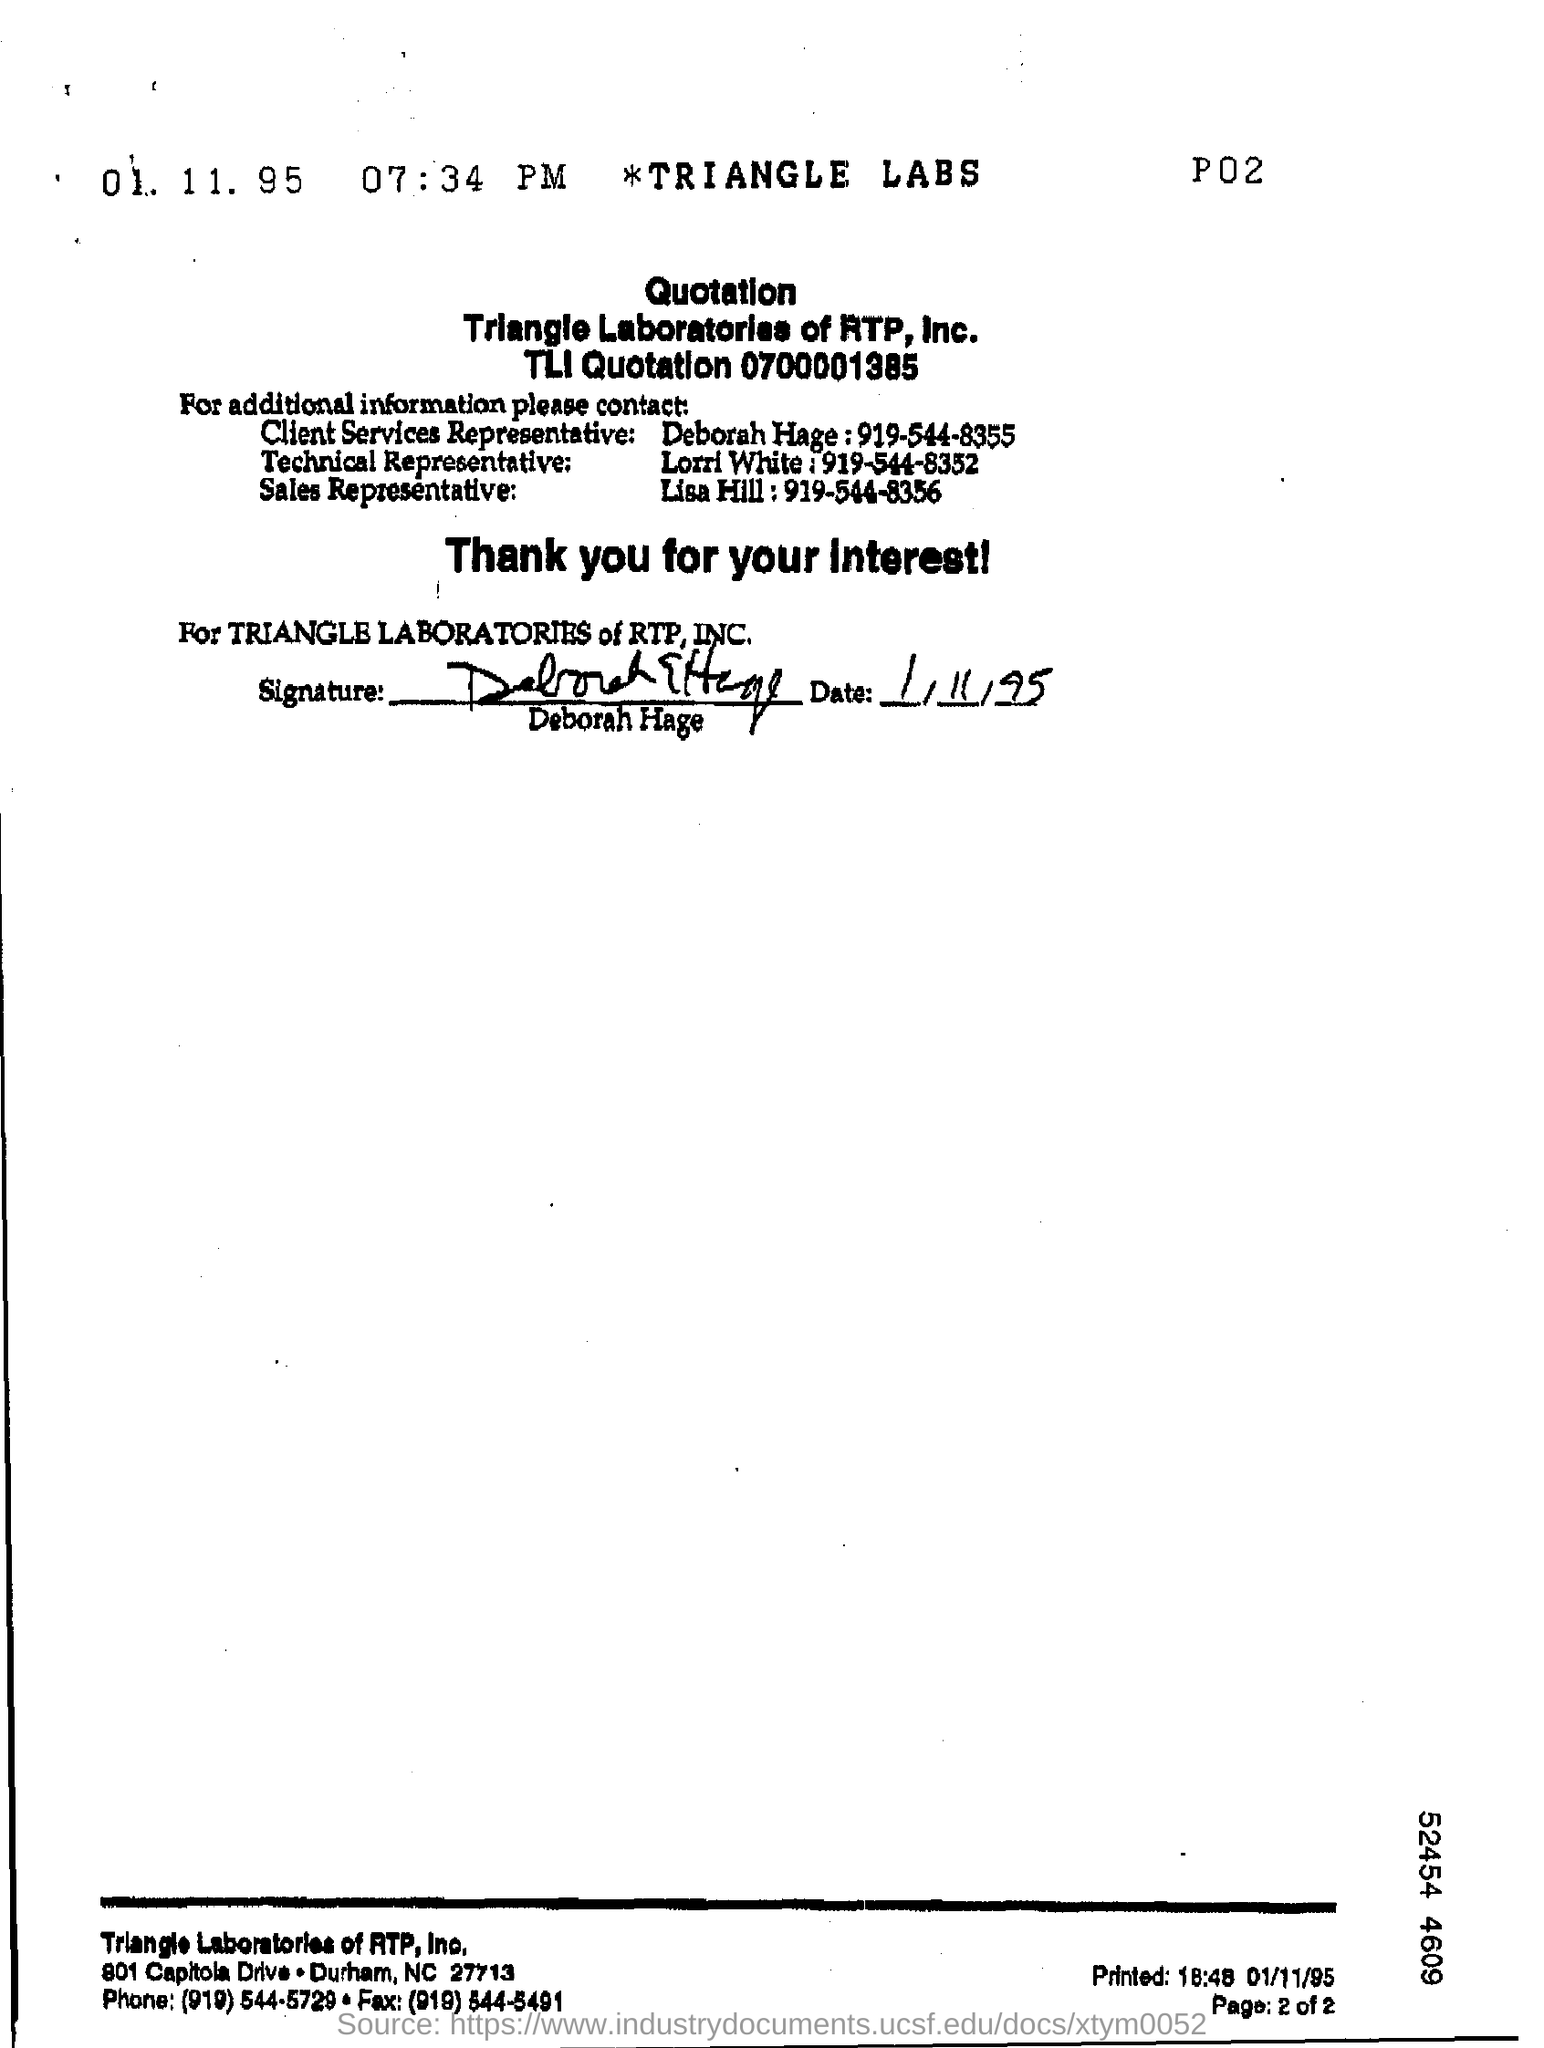What is the contact number of deborah hage ?
Make the answer very short. 919-544-8355. 